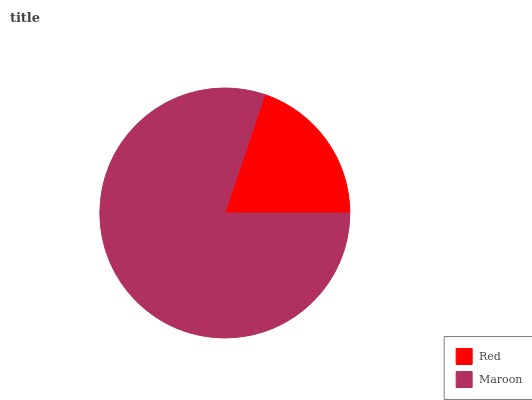Is Red the minimum?
Answer yes or no. Yes. Is Maroon the maximum?
Answer yes or no. Yes. Is Maroon the minimum?
Answer yes or no. No. Is Maroon greater than Red?
Answer yes or no. Yes. Is Red less than Maroon?
Answer yes or no. Yes. Is Red greater than Maroon?
Answer yes or no. No. Is Maroon less than Red?
Answer yes or no. No. Is Maroon the high median?
Answer yes or no. Yes. Is Red the low median?
Answer yes or no. Yes. Is Red the high median?
Answer yes or no. No. Is Maroon the low median?
Answer yes or no. No. 